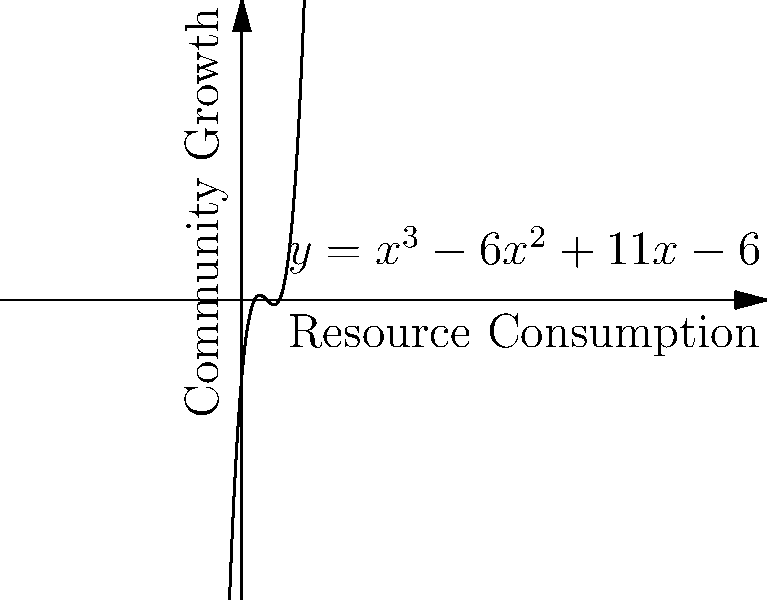In our humble community, we've observed that growth follows a polynomial pattern in relation to resource consumption. The graph shows this relationship, represented by the function $y = x^3 - 6x^2 + 11x - 6$, where $x$ is resource consumption and $y$ is community growth. At what point does the community's growth rate begin to increase faster than its resource consumption? How might this inform our stewardship of resources? To find where the community's growth rate begins to increase faster than resource consumption, we need to determine the inflection point of the polynomial function. This is where the curve changes from concave down to concave up.

Steps:
1. Find the second derivative of the function:
   $f(x) = x^3 - 6x^2 + 11x - 6$
   $f'(x) = 3x^2 - 12x + 11$
   $f''(x) = 6x - 12$

2. Set the second derivative to zero and solve for x:
   $6x - 12 = 0$
   $6x = 12$
   $x = 2$

3. Verify that this is indeed a change from concave down to concave up:
   For $x < 2$, $f''(x) < 0$ (concave down)
   For $x > 2$, $f''(x) > 0$ (concave up)

4. Calculate the y-coordinate at $x = 2$:
   $y = 2^3 - 6(2^2) + 11(2) - 6 = 8 - 24 + 22 - 6 = 0$

Therefore, the inflection point occurs at (2, 0). This means that when resource consumption reaches 2 units, the community's growth rate begins to increase faster than its resource consumption.

Interpretation: This inflection point suggests that after a certain level of resource consumption, the community experiences accelerated growth. As stewards of resources, we should be mindful of this tipping point. While growth is important, we must balance it with responsible resource use to maintain a sustainable and humble lifestyle.
Answer: At (2, 0); mindful resource management needed. 